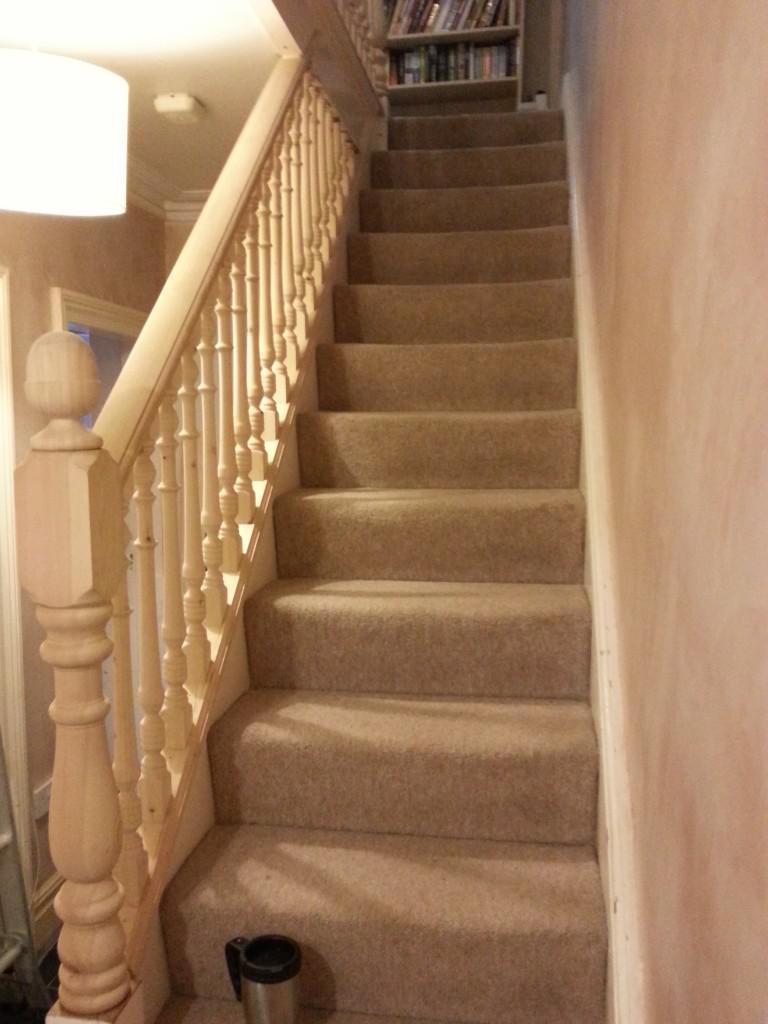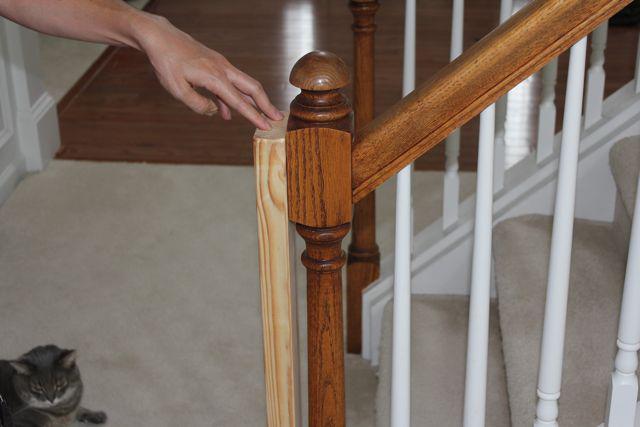The first image is the image on the left, the second image is the image on the right. Given the left and right images, does the statement "Each staircase has a banister." hold true? Answer yes or no. Yes. The first image is the image on the left, the second image is the image on the right. Considering the images on both sides, is "All of the staircases have vertical banisters for support." valid? Answer yes or no. Yes. 